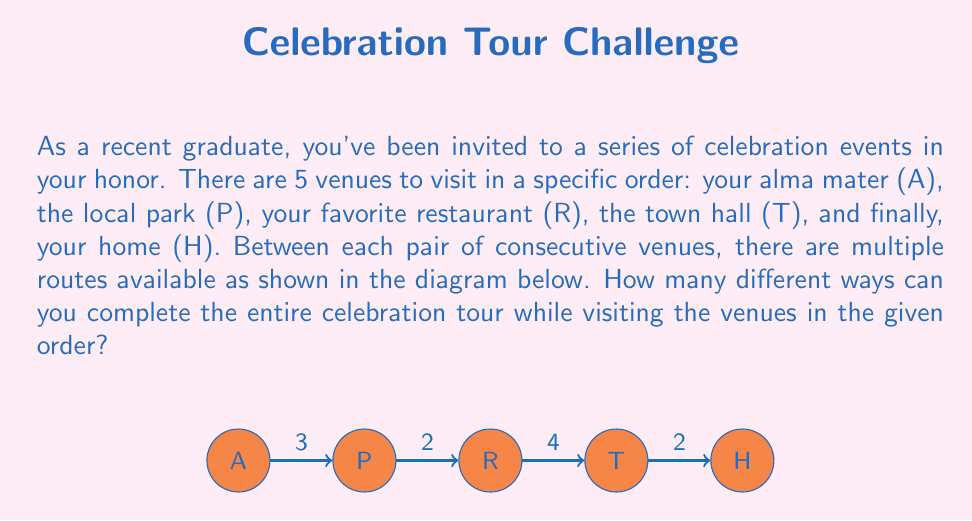Help me with this question. Let's approach this step-by-step using the multiplication principle of counting:

1) Between A and P, there are 3 routes.
2) Between P and R, there are 2 routes.
3) Between R and T, there are 4 routes.
4) Between T and H, there are 2 routes.

To find the total number of ways to complete the entire tour, we multiply the number of options for each segment:

$$\text{Total number of routes} = 3 \times 2 \times 4 \times 2$$

This is because for each choice of route from A to P, we have 2 choices from P to R, and for each of those, we have 4 choices from R to T, and so on.

Calculating:
$$3 \times 2 \times 4 \times 2 = 48$$

Therefore, there are 48 different ways to complete the entire celebration tour while visiting the venues in the given order.
Answer: 48 